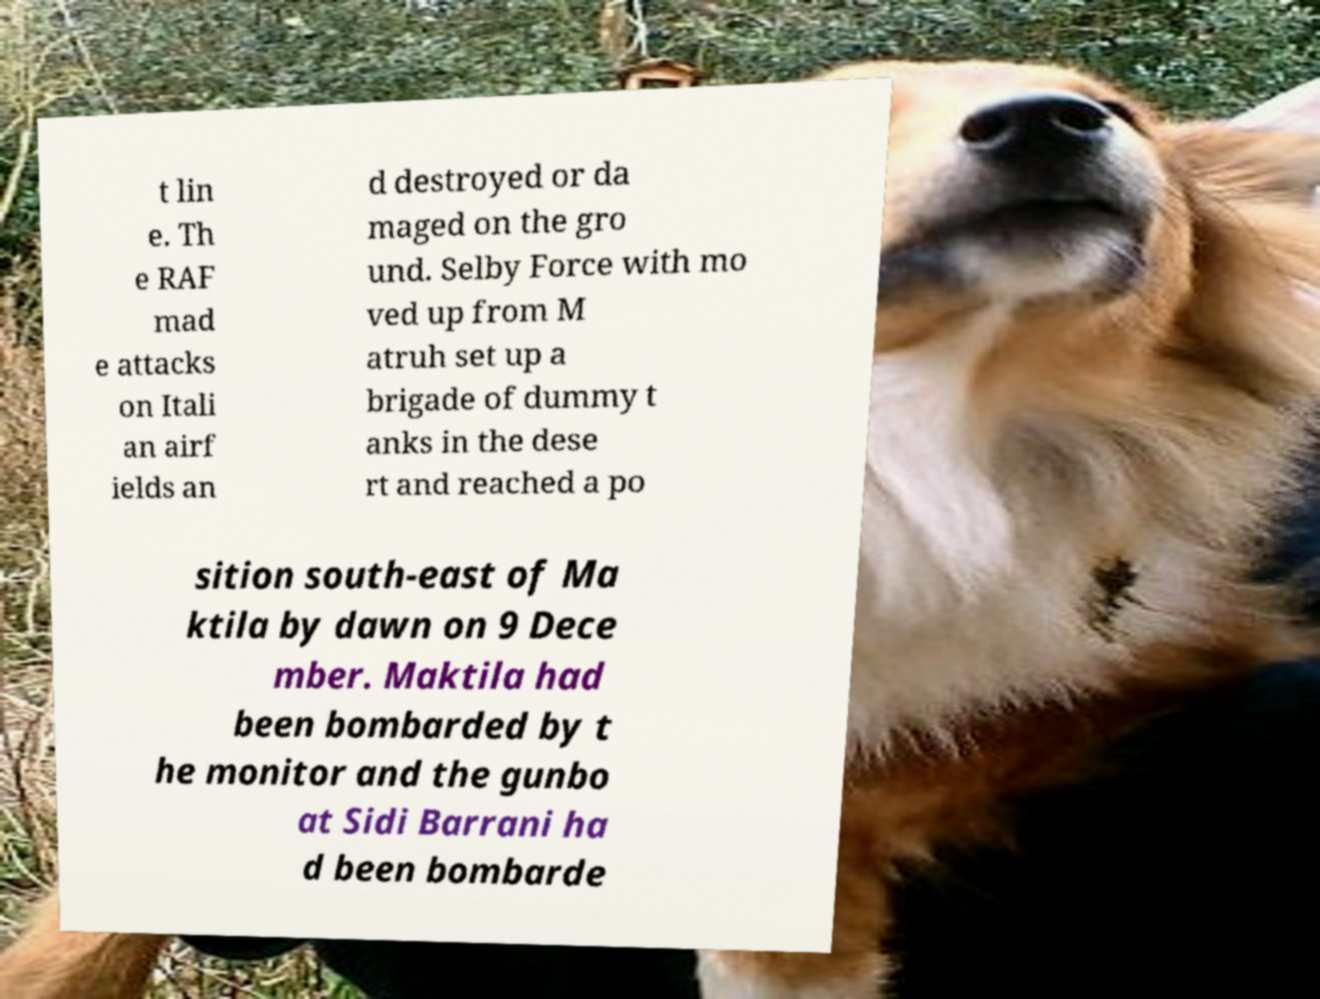Please read and relay the text visible in this image. What does it say? t lin e. Th e RAF mad e attacks on Itali an airf ields an d destroyed or da maged on the gro und. Selby Force with mo ved up from M atruh set up a brigade of dummy t anks in the dese rt and reached a po sition south-east of Ma ktila by dawn on 9 Dece mber. Maktila had been bombarded by t he monitor and the gunbo at Sidi Barrani ha d been bombarde 